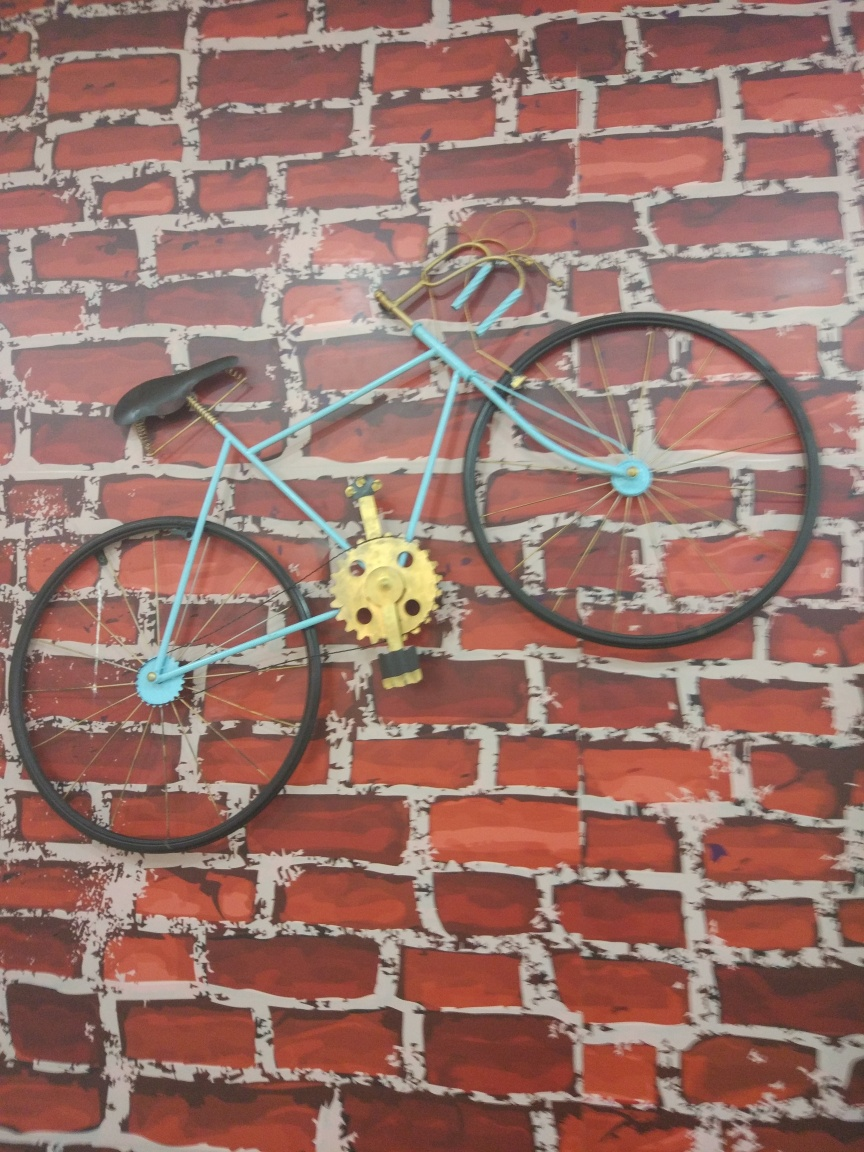Are the texture details of the bicycle rich and clear? The texture details on the bicycle are visible, but due to the image quality and the complex background, which mimics a brick wall, it might be challenging to discern all texture details clearly. The bicycle's body has a matte finish with no significant reflections, while the brick wall has a stylized, painted appearance with white accents highlighting the mortar lines. The interplay of the bicycle’s simple lines against the busy pattern of the wall creates a compelling visual, but it does not allow us to appreciate the texture in full detail. 